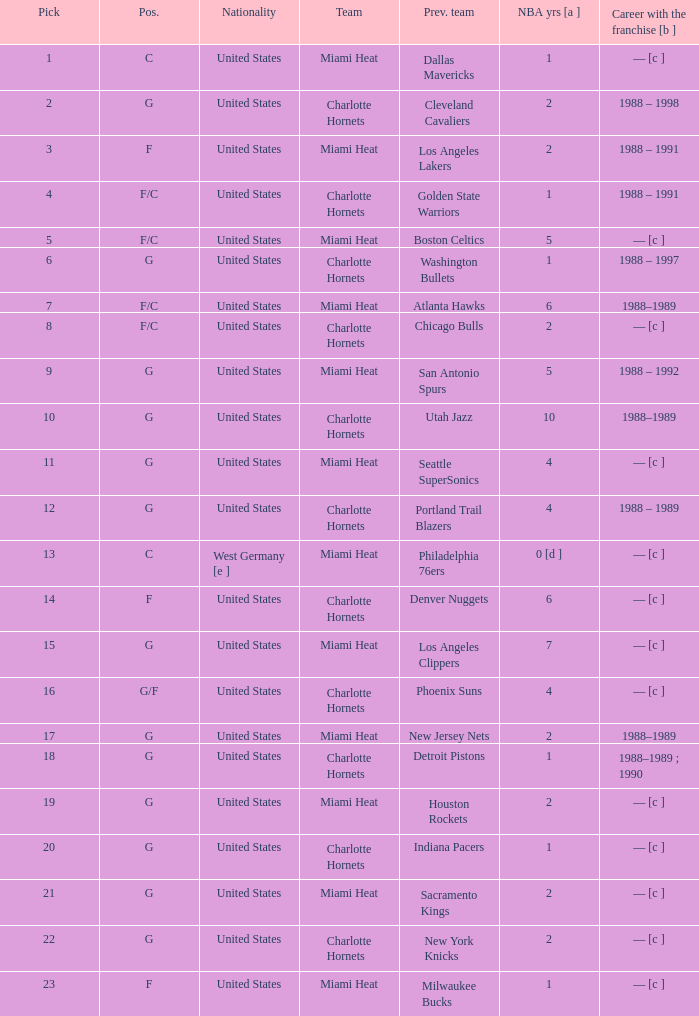How many NBA years did the player from the United States who was previously on the los angeles lakers have? 2.0. 